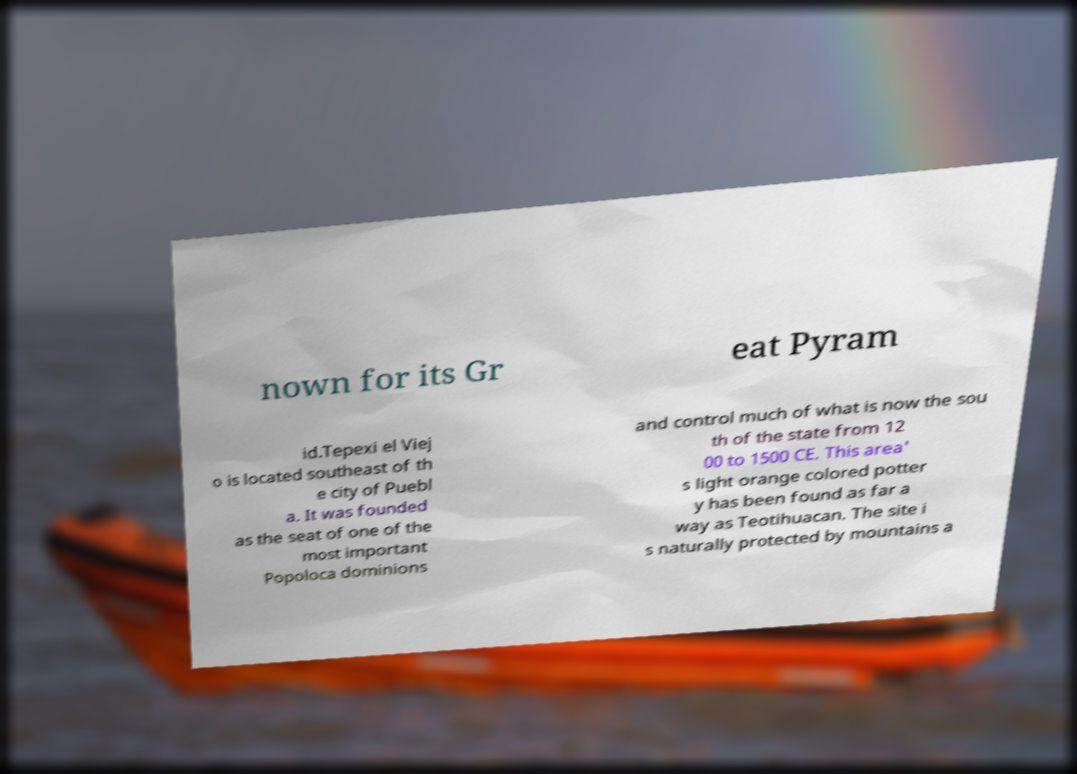Can you accurately transcribe the text from the provided image for me? nown for its Gr eat Pyram id.Tepexi el Viej o is located southeast of th e city of Puebl a. It was founded as the seat of one of the most important Popoloca dominions and control much of what is now the sou th of the state from 12 00 to 1500 CE. This area' s light orange colored potter y has been found as far a way as Teotihuacan. The site i s naturally protected by mountains a 